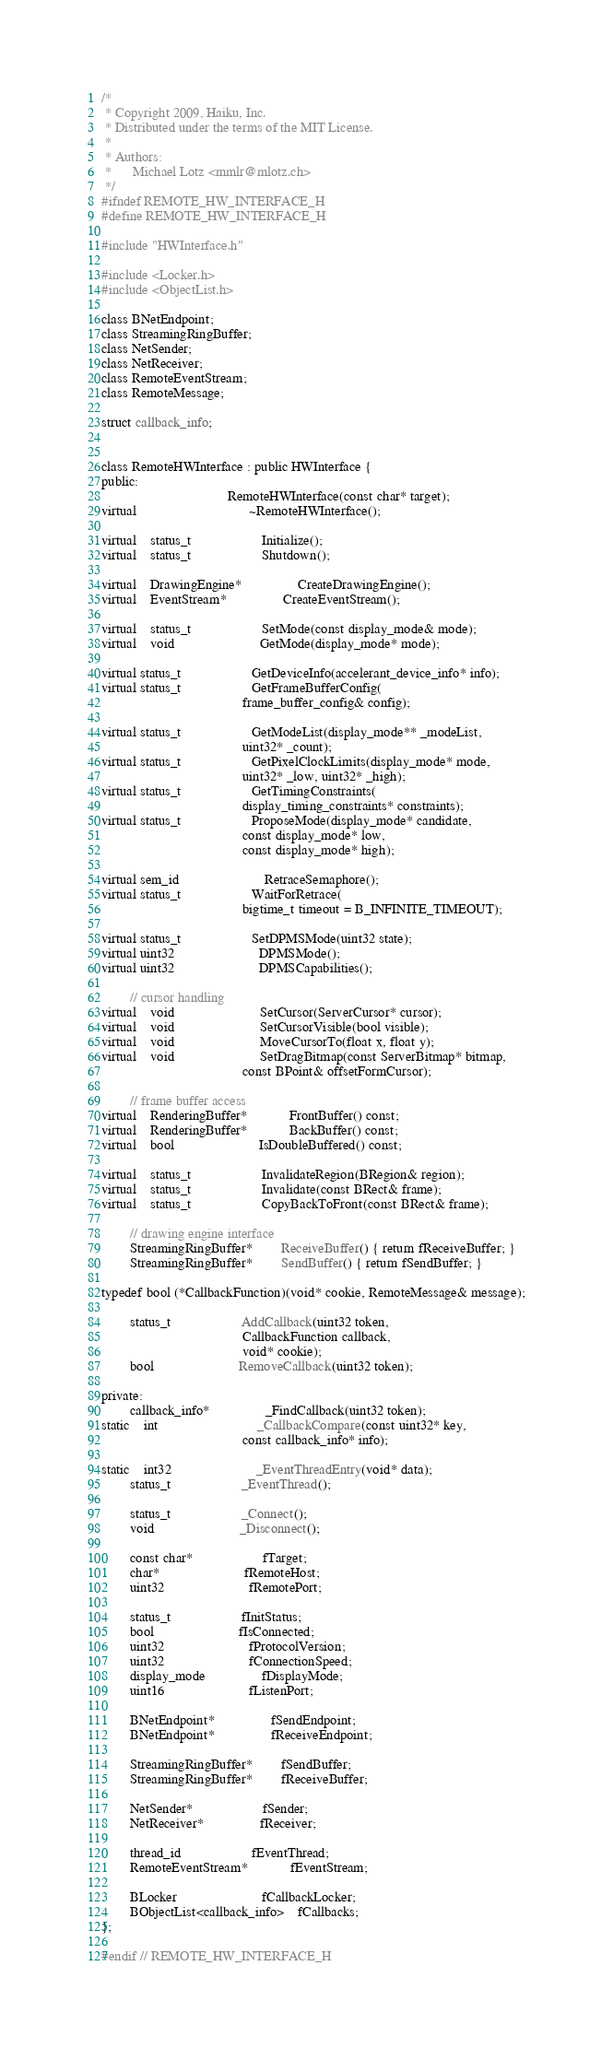Convert code to text. <code><loc_0><loc_0><loc_500><loc_500><_C_>/*
 * Copyright 2009, Haiku, Inc.
 * Distributed under the terms of the MIT License.
 *
 * Authors:
 *		Michael Lotz <mmlr@mlotz.ch>
 */
#ifndef REMOTE_HW_INTERFACE_H
#define REMOTE_HW_INTERFACE_H

#include "HWInterface.h"

#include <Locker.h>
#include <ObjectList.h>

class BNetEndpoint;
class StreamingRingBuffer;
class NetSender;
class NetReceiver;
class RemoteEventStream;
class RemoteMessage;

struct callback_info;


class RemoteHWInterface : public HWInterface {
public:
									RemoteHWInterface(const char* target);
virtual								~RemoteHWInterface();

virtual	status_t					Initialize();
virtual	status_t					Shutdown();

virtual	DrawingEngine*				CreateDrawingEngine();
virtual	EventStream*				CreateEventStream();

virtual	status_t					SetMode(const display_mode& mode);
virtual	void						GetMode(display_mode* mode);

virtual status_t					GetDeviceInfo(accelerant_device_info* info);
virtual status_t					GetFrameBufferConfig(
										frame_buffer_config& config);

virtual status_t					GetModeList(display_mode** _modeList,
										uint32* _count);
virtual status_t					GetPixelClockLimits(display_mode* mode,
										uint32* _low, uint32* _high);
virtual status_t					GetTimingConstraints(
										display_timing_constraints* constraints);
virtual status_t					ProposeMode(display_mode* candidate,
										const display_mode* low,
										const display_mode* high);

virtual sem_id						RetraceSemaphore();
virtual status_t					WaitForRetrace(
										bigtime_t timeout = B_INFINITE_TIMEOUT);

virtual status_t					SetDPMSMode(uint32 state);
virtual uint32						DPMSMode();
virtual uint32						DPMSCapabilities();

		// cursor handling
virtual	void						SetCursor(ServerCursor* cursor);
virtual	void						SetCursorVisible(bool visible);
virtual	void						MoveCursorTo(float x, float y);
virtual	void						SetDragBitmap(const ServerBitmap* bitmap,
										const BPoint& offsetFormCursor);

		// frame buffer access
virtual	RenderingBuffer*			FrontBuffer() const;
virtual	RenderingBuffer*			BackBuffer() const;
virtual	bool						IsDoubleBuffered() const;

virtual	status_t					InvalidateRegion(BRegion& region);
virtual	status_t					Invalidate(const BRect& frame);
virtual	status_t					CopyBackToFront(const BRect& frame);

		// drawing engine interface
		StreamingRingBuffer*		ReceiveBuffer() { return fReceiveBuffer; }
		StreamingRingBuffer*		SendBuffer() { return fSendBuffer; }

typedef bool (*CallbackFunction)(void* cookie, RemoteMessage& message);

		status_t					AddCallback(uint32 token,
										CallbackFunction callback,
										void* cookie);
		bool						RemoveCallback(uint32 token);

private:
		callback_info*				_FindCallback(uint32 token);
static	int							_CallbackCompare(const uint32* key,
										const callback_info* info);

static	int32						_EventThreadEntry(void* data);
		status_t					_EventThread();

		status_t					_Connect();
		void						_Disconnect();

		const char*					fTarget;
		char*						fRemoteHost;
		uint32						fRemotePort;

		status_t					fInitStatus;
		bool						fIsConnected;
		uint32						fProtocolVersion;
		uint32						fConnectionSpeed;
		display_mode				fDisplayMode;
		uint16						fListenPort;

		BNetEndpoint*				fSendEndpoint;
		BNetEndpoint*				fReceiveEndpoint;

		StreamingRingBuffer*		fSendBuffer;
		StreamingRingBuffer*		fReceiveBuffer;

		NetSender*					fSender;
		NetReceiver*				fReceiver;

		thread_id					fEventThread;
		RemoteEventStream*			fEventStream;

		BLocker						fCallbackLocker;
		BObjectList<callback_info>	fCallbacks;
};

#endif // REMOTE_HW_INTERFACE_H
</code> 